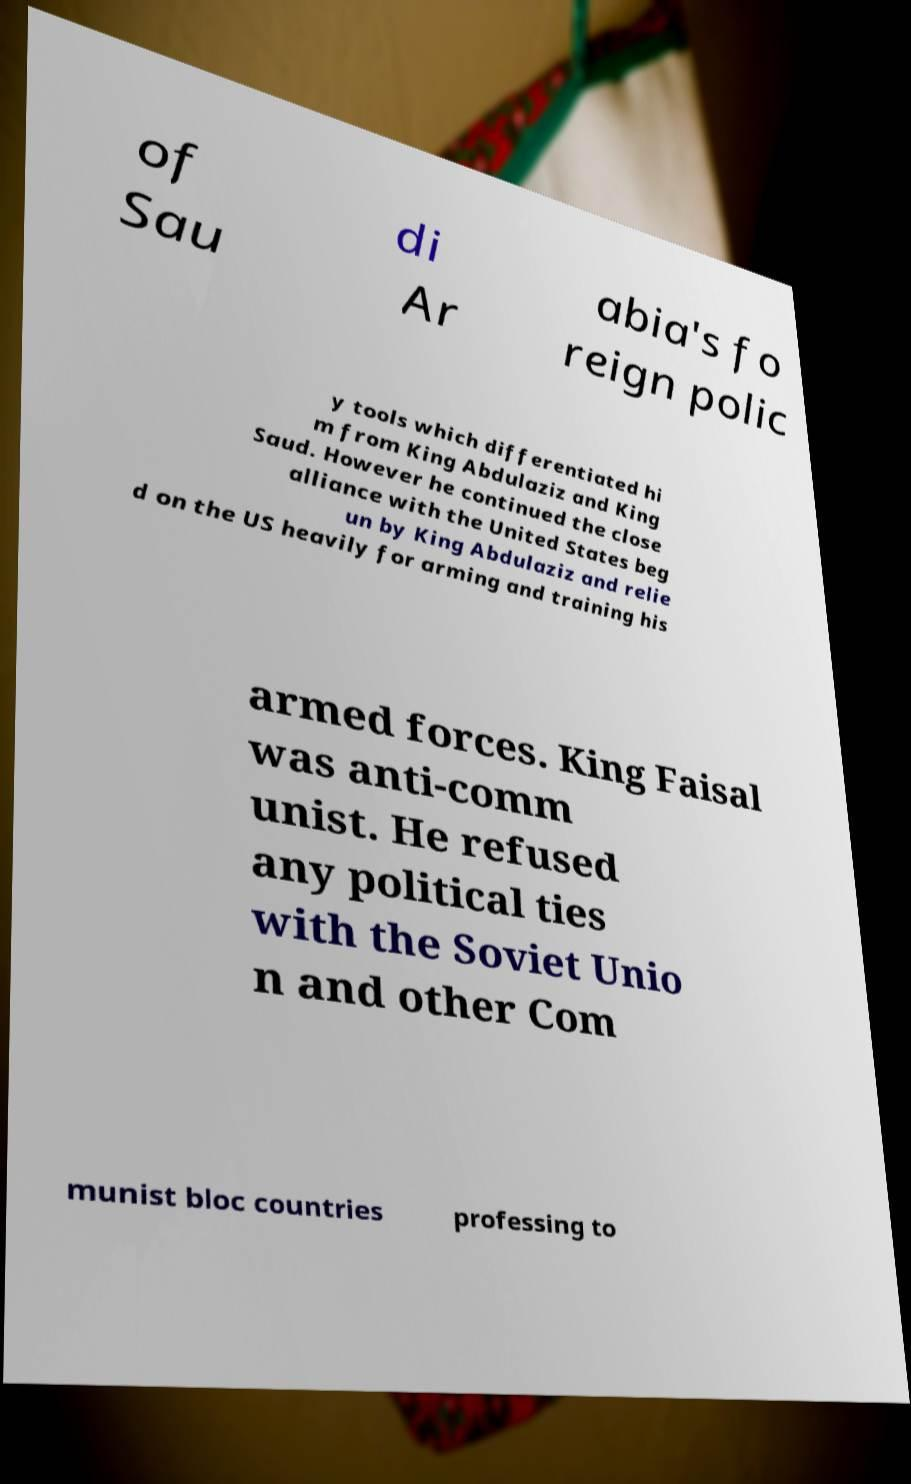Could you assist in decoding the text presented in this image and type it out clearly? of Sau di Ar abia's fo reign polic y tools which differentiated hi m from King Abdulaziz and King Saud. However he continued the close alliance with the United States beg un by King Abdulaziz and relie d on the US heavily for arming and training his armed forces. King Faisal was anti-comm unist. He refused any political ties with the Soviet Unio n and other Com munist bloc countries professing to 